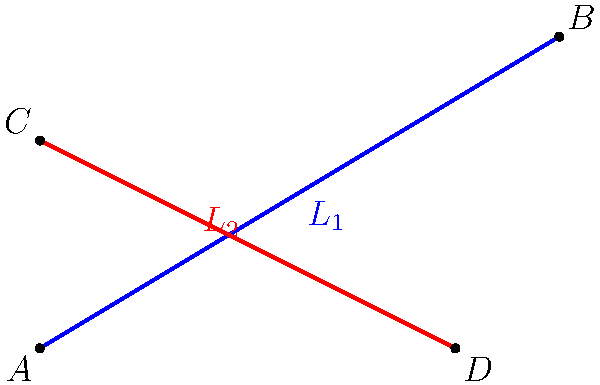In the coordinate plane, two lines $L_1$ and $L_2$ are shown. Line $L_1$ passes through points $A(0,0)$ and $B(5,3)$, while line $L_2$ passes through points $C(0,2)$ and $D(4,0)$. Calculate the acute angle between these two lines. To find the angle between two intersecting lines, we can use their slopes. Let's approach this step-by-step:

1) First, calculate the slopes of both lines:

   For $L_1$: $m_1 = \frac{y_B - y_A}{x_B - x_A} = \frac{3 - 0}{5 - 0} = \frac{3}{5}$

   For $L_2$: $m_2 = \frac{y_D - y_C}{x_D - x_C} = \frac{0 - 2}{4 - 0} = -\frac{1}{2}$

2) The formula for the angle $\theta$ between two lines with slopes $m_1$ and $m_2$ is:

   $\tan \theta = |\frac{m_1 - m_2}{1 + m_1m_2}|$

3) Substituting our values:

   $\tan \theta = |\frac{\frac{3}{5} - (-\frac{1}{2})}{1 + \frac{3}{5}(-\frac{1}{2})}|$

4) Simplify:
   
   $\tan \theta = |\frac{\frac{3}{5} + \frac{1}{2}}{1 - \frac{3}{10}}| = |\frac{\frac{6}{10} + \frac{5}{10}}{\frac{10}{10} - \frac{3}{10}}| = |\frac{\frac{11}{10}}{\frac{7}{10}}| = \frac{11}{7}$

5) To find $\theta$, we take the inverse tangent (arctangent):

   $\theta = \arctan(\frac{11}{7})$

6) Using a calculator or trigonometric tables, we find:

   $\theta \approx 57.54°$

This is the acute angle between the two lines.
Answer: $57.54°$ 